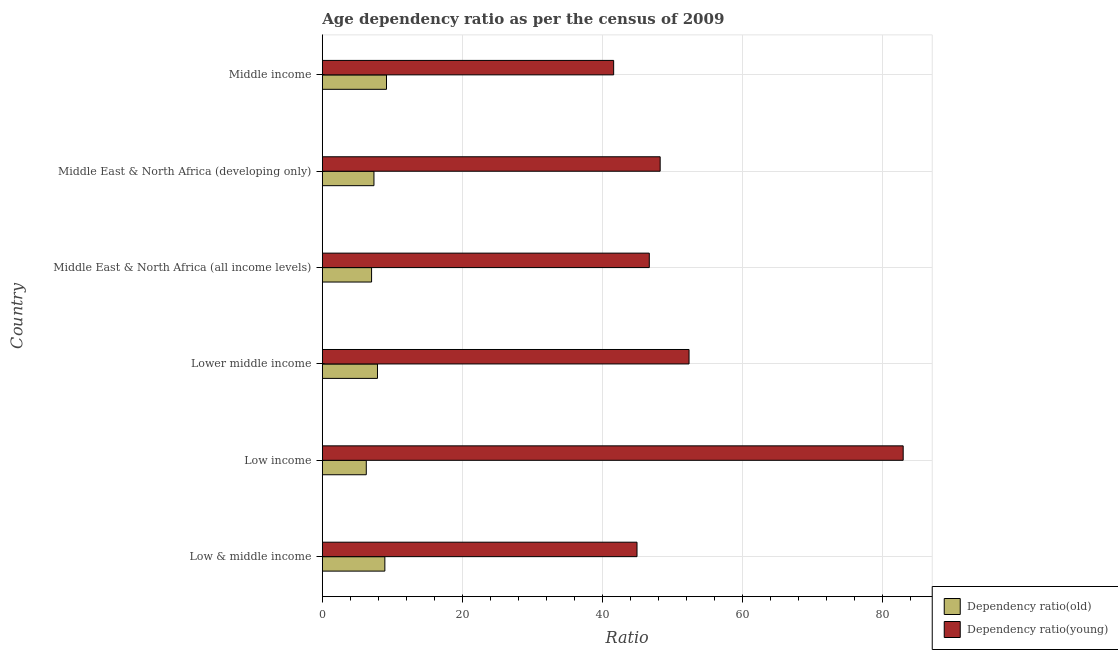How many different coloured bars are there?
Provide a succinct answer. 2. Are the number of bars per tick equal to the number of legend labels?
Your response must be concise. Yes. How many bars are there on the 4th tick from the bottom?
Make the answer very short. 2. In how many cases, is the number of bars for a given country not equal to the number of legend labels?
Your answer should be very brief. 0. What is the age dependency ratio(young) in Middle income?
Keep it short and to the point. 41.59. Across all countries, what is the maximum age dependency ratio(young)?
Make the answer very short. 82.92. Across all countries, what is the minimum age dependency ratio(young)?
Ensure brevity in your answer.  41.59. What is the total age dependency ratio(young) in the graph?
Ensure brevity in your answer.  316.68. What is the difference between the age dependency ratio(young) in Low & middle income and that in Middle East & North Africa (developing only)?
Offer a very short reply. -3.31. What is the difference between the age dependency ratio(old) in Middle income and the age dependency ratio(young) in Low & middle income?
Keep it short and to the point. -35.76. What is the average age dependency ratio(old) per country?
Provide a short and direct response. 7.77. What is the difference between the age dependency ratio(young) and age dependency ratio(old) in Middle East & North Africa (developing only)?
Your answer should be very brief. 40.86. In how many countries, is the age dependency ratio(old) greater than 56 ?
Your answer should be very brief. 0. What is the ratio of the age dependency ratio(young) in Middle East & North Africa (developing only) to that in Middle income?
Your answer should be compact. 1.16. Is the age dependency ratio(old) in Low income less than that in Middle East & North Africa (developing only)?
Ensure brevity in your answer.  Yes. What is the difference between the highest and the second highest age dependency ratio(old)?
Your response must be concise. 0.23. What is the difference between the highest and the lowest age dependency ratio(old)?
Offer a terse response. 2.89. What does the 2nd bar from the top in Middle income represents?
Your answer should be compact. Dependency ratio(old). What does the 1st bar from the bottom in Middle income represents?
Give a very brief answer. Dependency ratio(old). Are all the bars in the graph horizontal?
Provide a short and direct response. Yes. What is the difference between two consecutive major ticks on the X-axis?
Give a very brief answer. 20. What is the title of the graph?
Your response must be concise. Age dependency ratio as per the census of 2009. Does "Investment in Telecom" appear as one of the legend labels in the graph?
Keep it short and to the point. No. What is the label or title of the X-axis?
Ensure brevity in your answer.  Ratio. What is the label or title of the Y-axis?
Keep it short and to the point. Country. What is the Ratio of Dependency ratio(old) in Low & middle income?
Your answer should be compact. 8.93. What is the Ratio of Dependency ratio(young) in Low & middle income?
Provide a succinct answer. 44.92. What is the Ratio in Dependency ratio(old) in Low income?
Give a very brief answer. 6.27. What is the Ratio in Dependency ratio(young) in Low income?
Make the answer very short. 82.92. What is the Ratio in Dependency ratio(old) in Lower middle income?
Your answer should be very brief. 7.87. What is the Ratio in Dependency ratio(young) in Lower middle income?
Provide a short and direct response. 52.35. What is the Ratio in Dependency ratio(old) in Middle East & North Africa (all income levels)?
Offer a very short reply. 7.03. What is the Ratio of Dependency ratio(young) in Middle East & North Africa (all income levels)?
Offer a very short reply. 46.68. What is the Ratio in Dependency ratio(old) in Middle East & North Africa (developing only)?
Offer a terse response. 7.37. What is the Ratio in Dependency ratio(young) in Middle East & North Africa (developing only)?
Provide a succinct answer. 48.23. What is the Ratio in Dependency ratio(old) in Middle income?
Offer a terse response. 9.16. What is the Ratio in Dependency ratio(young) in Middle income?
Keep it short and to the point. 41.59. Across all countries, what is the maximum Ratio in Dependency ratio(old)?
Provide a succinct answer. 9.16. Across all countries, what is the maximum Ratio of Dependency ratio(young)?
Keep it short and to the point. 82.92. Across all countries, what is the minimum Ratio of Dependency ratio(old)?
Keep it short and to the point. 6.27. Across all countries, what is the minimum Ratio in Dependency ratio(young)?
Your answer should be very brief. 41.59. What is the total Ratio of Dependency ratio(old) in the graph?
Your answer should be very brief. 46.63. What is the total Ratio in Dependency ratio(young) in the graph?
Give a very brief answer. 316.68. What is the difference between the Ratio of Dependency ratio(old) in Low & middle income and that in Low income?
Keep it short and to the point. 2.65. What is the difference between the Ratio of Dependency ratio(young) in Low & middle income and that in Low income?
Provide a succinct answer. -38. What is the difference between the Ratio of Dependency ratio(old) in Low & middle income and that in Lower middle income?
Provide a succinct answer. 1.05. What is the difference between the Ratio of Dependency ratio(young) in Low & middle income and that in Lower middle income?
Keep it short and to the point. -7.43. What is the difference between the Ratio in Dependency ratio(old) in Low & middle income and that in Middle East & North Africa (all income levels)?
Keep it short and to the point. 1.9. What is the difference between the Ratio in Dependency ratio(young) in Low & middle income and that in Middle East & North Africa (all income levels)?
Your answer should be compact. -1.75. What is the difference between the Ratio in Dependency ratio(old) in Low & middle income and that in Middle East & North Africa (developing only)?
Provide a short and direct response. 1.56. What is the difference between the Ratio in Dependency ratio(young) in Low & middle income and that in Middle East & North Africa (developing only)?
Your answer should be compact. -3.31. What is the difference between the Ratio in Dependency ratio(old) in Low & middle income and that in Middle income?
Your answer should be compact. -0.23. What is the difference between the Ratio in Dependency ratio(young) in Low & middle income and that in Middle income?
Provide a succinct answer. 3.33. What is the difference between the Ratio of Dependency ratio(old) in Low income and that in Lower middle income?
Provide a short and direct response. -1.6. What is the difference between the Ratio in Dependency ratio(young) in Low income and that in Lower middle income?
Your response must be concise. 30.57. What is the difference between the Ratio in Dependency ratio(old) in Low income and that in Middle East & North Africa (all income levels)?
Offer a terse response. -0.76. What is the difference between the Ratio in Dependency ratio(young) in Low income and that in Middle East & North Africa (all income levels)?
Give a very brief answer. 36.24. What is the difference between the Ratio in Dependency ratio(old) in Low income and that in Middle East & North Africa (developing only)?
Ensure brevity in your answer.  -1.1. What is the difference between the Ratio in Dependency ratio(young) in Low income and that in Middle East & North Africa (developing only)?
Keep it short and to the point. 34.69. What is the difference between the Ratio in Dependency ratio(old) in Low income and that in Middle income?
Keep it short and to the point. -2.89. What is the difference between the Ratio in Dependency ratio(young) in Low income and that in Middle income?
Your answer should be compact. 41.33. What is the difference between the Ratio of Dependency ratio(old) in Lower middle income and that in Middle East & North Africa (all income levels)?
Your answer should be very brief. 0.84. What is the difference between the Ratio in Dependency ratio(young) in Lower middle income and that in Middle East & North Africa (all income levels)?
Your answer should be very brief. 5.67. What is the difference between the Ratio of Dependency ratio(old) in Lower middle income and that in Middle East & North Africa (developing only)?
Your answer should be very brief. 0.5. What is the difference between the Ratio of Dependency ratio(young) in Lower middle income and that in Middle East & North Africa (developing only)?
Give a very brief answer. 4.12. What is the difference between the Ratio of Dependency ratio(old) in Lower middle income and that in Middle income?
Offer a terse response. -1.29. What is the difference between the Ratio of Dependency ratio(young) in Lower middle income and that in Middle income?
Provide a short and direct response. 10.76. What is the difference between the Ratio in Dependency ratio(old) in Middle East & North Africa (all income levels) and that in Middle East & North Africa (developing only)?
Your answer should be compact. -0.34. What is the difference between the Ratio in Dependency ratio(young) in Middle East & North Africa (all income levels) and that in Middle East & North Africa (developing only)?
Give a very brief answer. -1.55. What is the difference between the Ratio of Dependency ratio(old) in Middle East & North Africa (all income levels) and that in Middle income?
Offer a terse response. -2.13. What is the difference between the Ratio of Dependency ratio(young) in Middle East & North Africa (all income levels) and that in Middle income?
Provide a succinct answer. 5.09. What is the difference between the Ratio of Dependency ratio(old) in Middle East & North Africa (developing only) and that in Middle income?
Your answer should be very brief. -1.79. What is the difference between the Ratio of Dependency ratio(young) in Middle East & North Africa (developing only) and that in Middle income?
Ensure brevity in your answer.  6.64. What is the difference between the Ratio in Dependency ratio(old) in Low & middle income and the Ratio in Dependency ratio(young) in Low income?
Offer a terse response. -73.99. What is the difference between the Ratio in Dependency ratio(old) in Low & middle income and the Ratio in Dependency ratio(young) in Lower middle income?
Offer a terse response. -43.42. What is the difference between the Ratio of Dependency ratio(old) in Low & middle income and the Ratio of Dependency ratio(young) in Middle East & North Africa (all income levels)?
Keep it short and to the point. -37.75. What is the difference between the Ratio of Dependency ratio(old) in Low & middle income and the Ratio of Dependency ratio(young) in Middle East & North Africa (developing only)?
Offer a very short reply. -39.3. What is the difference between the Ratio of Dependency ratio(old) in Low & middle income and the Ratio of Dependency ratio(young) in Middle income?
Offer a terse response. -32.66. What is the difference between the Ratio in Dependency ratio(old) in Low income and the Ratio in Dependency ratio(young) in Lower middle income?
Your response must be concise. -46.08. What is the difference between the Ratio of Dependency ratio(old) in Low income and the Ratio of Dependency ratio(young) in Middle East & North Africa (all income levels)?
Your answer should be very brief. -40.4. What is the difference between the Ratio of Dependency ratio(old) in Low income and the Ratio of Dependency ratio(young) in Middle East & North Africa (developing only)?
Your answer should be compact. -41.96. What is the difference between the Ratio of Dependency ratio(old) in Low income and the Ratio of Dependency ratio(young) in Middle income?
Offer a very short reply. -35.31. What is the difference between the Ratio of Dependency ratio(old) in Lower middle income and the Ratio of Dependency ratio(young) in Middle East & North Africa (all income levels)?
Your response must be concise. -38.8. What is the difference between the Ratio of Dependency ratio(old) in Lower middle income and the Ratio of Dependency ratio(young) in Middle East & North Africa (developing only)?
Offer a very short reply. -40.36. What is the difference between the Ratio of Dependency ratio(old) in Lower middle income and the Ratio of Dependency ratio(young) in Middle income?
Your response must be concise. -33.72. What is the difference between the Ratio of Dependency ratio(old) in Middle East & North Africa (all income levels) and the Ratio of Dependency ratio(young) in Middle East & North Africa (developing only)?
Offer a terse response. -41.2. What is the difference between the Ratio in Dependency ratio(old) in Middle East & North Africa (all income levels) and the Ratio in Dependency ratio(young) in Middle income?
Your answer should be very brief. -34.56. What is the difference between the Ratio in Dependency ratio(old) in Middle East & North Africa (developing only) and the Ratio in Dependency ratio(young) in Middle income?
Make the answer very short. -34.22. What is the average Ratio of Dependency ratio(old) per country?
Your answer should be compact. 7.77. What is the average Ratio in Dependency ratio(young) per country?
Make the answer very short. 52.78. What is the difference between the Ratio of Dependency ratio(old) and Ratio of Dependency ratio(young) in Low & middle income?
Keep it short and to the point. -35.99. What is the difference between the Ratio in Dependency ratio(old) and Ratio in Dependency ratio(young) in Low income?
Make the answer very short. -76.65. What is the difference between the Ratio of Dependency ratio(old) and Ratio of Dependency ratio(young) in Lower middle income?
Keep it short and to the point. -44.48. What is the difference between the Ratio of Dependency ratio(old) and Ratio of Dependency ratio(young) in Middle East & North Africa (all income levels)?
Your response must be concise. -39.65. What is the difference between the Ratio in Dependency ratio(old) and Ratio in Dependency ratio(young) in Middle East & North Africa (developing only)?
Offer a terse response. -40.86. What is the difference between the Ratio of Dependency ratio(old) and Ratio of Dependency ratio(young) in Middle income?
Provide a short and direct response. -32.43. What is the ratio of the Ratio of Dependency ratio(old) in Low & middle income to that in Low income?
Ensure brevity in your answer.  1.42. What is the ratio of the Ratio in Dependency ratio(young) in Low & middle income to that in Low income?
Your response must be concise. 0.54. What is the ratio of the Ratio of Dependency ratio(old) in Low & middle income to that in Lower middle income?
Your answer should be very brief. 1.13. What is the ratio of the Ratio in Dependency ratio(young) in Low & middle income to that in Lower middle income?
Ensure brevity in your answer.  0.86. What is the ratio of the Ratio in Dependency ratio(old) in Low & middle income to that in Middle East & North Africa (all income levels)?
Your answer should be very brief. 1.27. What is the ratio of the Ratio of Dependency ratio(young) in Low & middle income to that in Middle East & North Africa (all income levels)?
Ensure brevity in your answer.  0.96. What is the ratio of the Ratio in Dependency ratio(old) in Low & middle income to that in Middle East & North Africa (developing only)?
Your response must be concise. 1.21. What is the ratio of the Ratio of Dependency ratio(young) in Low & middle income to that in Middle East & North Africa (developing only)?
Give a very brief answer. 0.93. What is the ratio of the Ratio in Dependency ratio(old) in Low & middle income to that in Middle income?
Provide a short and direct response. 0.97. What is the ratio of the Ratio in Dependency ratio(young) in Low & middle income to that in Middle income?
Offer a very short reply. 1.08. What is the ratio of the Ratio of Dependency ratio(old) in Low income to that in Lower middle income?
Provide a succinct answer. 0.8. What is the ratio of the Ratio of Dependency ratio(young) in Low income to that in Lower middle income?
Provide a succinct answer. 1.58. What is the ratio of the Ratio in Dependency ratio(old) in Low income to that in Middle East & North Africa (all income levels)?
Your answer should be very brief. 0.89. What is the ratio of the Ratio of Dependency ratio(young) in Low income to that in Middle East & North Africa (all income levels)?
Your answer should be very brief. 1.78. What is the ratio of the Ratio in Dependency ratio(old) in Low income to that in Middle East & North Africa (developing only)?
Ensure brevity in your answer.  0.85. What is the ratio of the Ratio in Dependency ratio(young) in Low income to that in Middle East & North Africa (developing only)?
Offer a terse response. 1.72. What is the ratio of the Ratio in Dependency ratio(old) in Low income to that in Middle income?
Your answer should be compact. 0.68. What is the ratio of the Ratio of Dependency ratio(young) in Low income to that in Middle income?
Offer a very short reply. 1.99. What is the ratio of the Ratio of Dependency ratio(old) in Lower middle income to that in Middle East & North Africa (all income levels)?
Offer a terse response. 1.12. What is the ratio of the Ratio of Dependency ratio(young) in Lower middle income to that in Middle East & North Africa (all income levels)?
Offer a very short reply. 1.12. What is the ratio of the Ratio of Dependency ratio(old) in Lower middle income to that in Middle East & North Africa (developing only)?
Your response must be concise. 1.07. What is the ratio of the Ratio in Dependency ratio(young) in Lower middle income to that in Middle East & North Africa (developing only)?
Give a very brief answer. 1.09. What is the ratio of the Ratio of Dependency ratio(old) in Lower middle income to that in Middle income?
Provide a short and direct response. 0.86. What is the ratio of the Ratio of Dependency ratio(young) in Lower middle income to that in Middle income?
Offer a very short reply. 1.26. What is the ratio of the Ratio in Dependency ratio(old) in Middle East & North Africa (all income levels) to that in Middle East & North Africa (developing only)?
Provide a short and direct response. 0.95. What is the ratio of the Ratio of Dependency ratio(young) in Middle East & North Africa (all income levels) to that in Middle East & North Africa (developing only)?
Your response must be concise. 0.97. What is the ratio of the Ratio in Dependency ratio(old) in Middle East & North Africa (all income levels) to that in Middle income?
Offer a terse response. 0.77. What is the ratio of the Ratio in Dependency ratio(young) in Middle East & North Africa (all income levels) to that in Middle income?
Keep it short and to the point. 1.12. What is the ratio of the Ratio of Dependency ratio(old) in Middle East & North Africa (developing only) to that in Middle income?
Provide a succinct answer. 0.8. What is the ratio of the Ratio of Dependency ratio(young) in Middle East & North Africa (developing only) to that in Middle income?
Keep it short and to the point. 1.16. What is the difference between the highest and the second highest Ratio in Dependency ratio(old)?
Provide a short and direct response. 0.23. What is the difference between the highest and the second highest Ratio of Dependency ratio(young)?
Offer a terse response. 30.57. What is the difference between the highest and the lowest Ratio of Dependency ratio(old)?
Your answer should be very brief. 2.89. What is the difference between the highest and the lowest Ratio in Dependency ratio(young)?
Give a very brief answer. 41.33. 